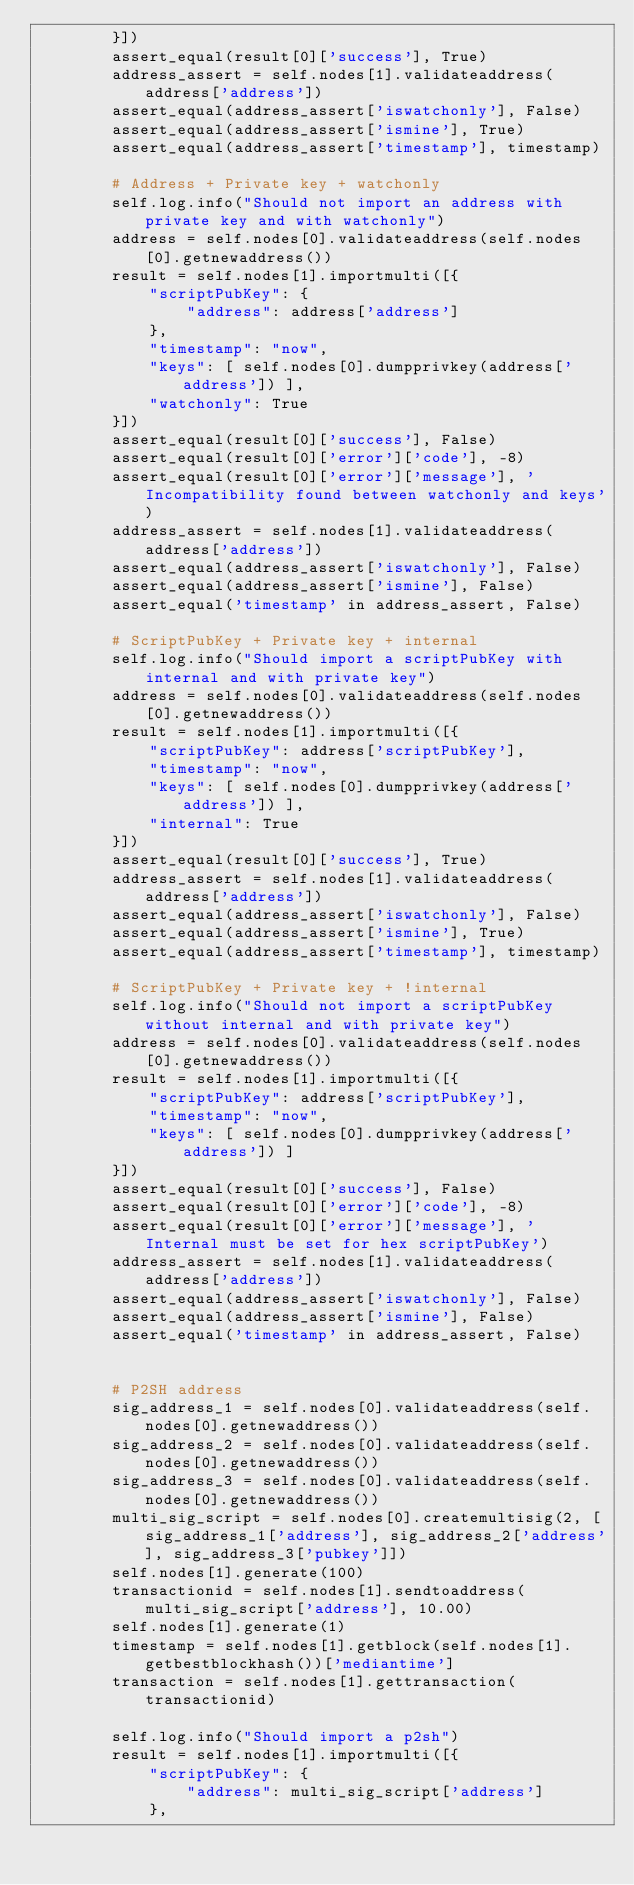<code> <loc_0><loc_0><loc_500><loc_500><_Python_>        }])
        assert_equal(result[0]['success'], True)
        address_assert = self.nodes[1].validateaddress(address['address'])
        assert_equal(address_assert['iswatchonly'], False)
        assert_equal(address_assert['ismine'], True)
        assert_equal(address_assert['timestamp'], timestamp)

        # Address + Private key + watchonly
        self.log.info("Should not import an address with private key and with watchonly")
        address = self.nodes[0].validateaddress(self.nodes[0].getnewaddress())
        result = self.nodes[1].importmulti([{
            "scriptPubKey": {
                "address": address['address']
            },
            "timestamp": "now",
            "keys": [ self.nodes[0].dumpprivkey(address['address']) ],
            "watchonly": True
        }])
        assert_equal(result[0]['success'], False)
        assert_equal(result[0]['error']['code'], -8)
        assert_equal(result[0]['error']['message'], 'Incompatibility found between watchonly and keys')
        address_assert = self.nodes[1].validateaddress(address['address'])
        assert_equal(address_assert['iswatchonly'], False)
        assert_equal(address_assert['ismine'], False)
        assert_equal('timestamp' in address_assert, False)

        # ScriptPubKey + Private key + internal
        self.log.info("Should import a scriptPubKey with internal and with private key")
        address = self.nodes[0].validateaddress(self.nodes[0].getnewaddress())
        result = self.nodes[1].importmulti([{
            "scriptPubKey": address['scriptPubKey'],
            "timestamp": "now",
            "keys": [ self.nodes[0].dumpprivkey(address['address']) ],
            "internal": True
        }])
        assert_equal(result[0]['success'], True)
        address_assert = self.nodes[1].validateaddress(address['address'])
        assert_equal(address_assert['iswatchonly'], False)
        assert_equal(address_assert['ismine'], True)
        assert_equal(address_assert['timestamp'], timestamp)

        # ScriptPubKey + Private key + !internal
        self.log.info("Should not import a scriptPubKey without internal and with private key")
        address = self.nodes[0].validateaddress(self.nodes[0].getnewaddress())
        result = self.nodes[1].importmulti([{
            "scriptPubKey": address['scriptPubKey'],
            "timestamp": "now",
            "keys": [ self.nodes[0].dumpprivkey(address['address']) ]
        }])
        assert_equal(result[0]['success'], False)
        assert_equal(result[0]['error']['code'], -8)
        assert_equal(result[0]['error']['message'], 'Internal must be set for hex scriptPubKey')
        address_assert = self.nodes[1].validateaddress(address['address'])
        assert_equal(address_assert['iswatchonly'], False)
        assert_equal(address_assert['ismine'], False)
        assert_equal('timestamp' in address_assert, False)


        # P2SH address
        sig_address_1 = self.nodes[0].validateaddress(self.nodes[0].getnewaddress())
        sig_address_2 = self.nodes[0].validateaddress(self.nodes[0].getnewaddress())
        sig_address_3 = self.nodes[0].validateaddress(self.nodes[0].getnewaddress())
        multi_sig_script = self.nodes[0].createmultisig(2, [sig_address_1['address'], sig_address_2['address'], sig_address_3['pubkey']])
        self.nodes[1].generate(100)
        transactionid = self.nodes[1].sendtoaddress(multi_sig_script['address'], 10.00)
        self.nodes[1].generate(1)
        timestamp = self.nodes[1].getblock(self.nodes[1].getbestblockhash())['mediantime']
        transaction = self.nodes[1].gettransaction(transactionid)

        self.log.info("Should import a p2sh")
        result = self.nodes[1].importmulti([{
            "scriptPubKey": {
                "address": multi_sig_script['address']
            },</code> 